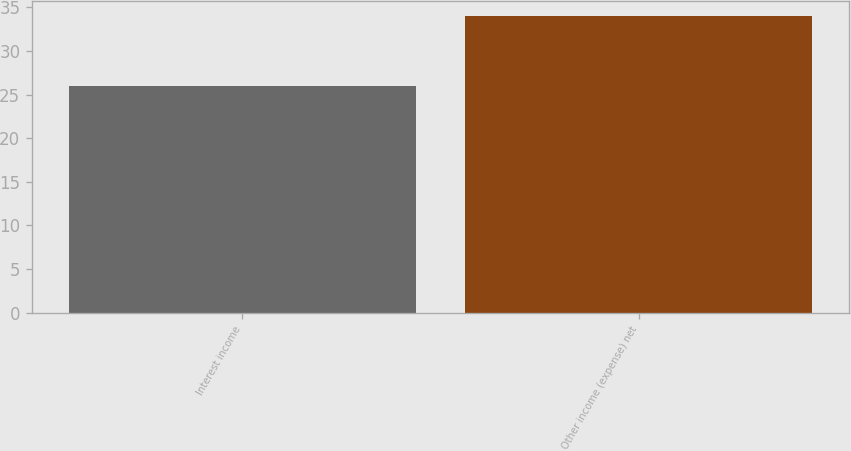Convert chart to OTSL. <chart><loc_0><loc_0><loc_500><loc_500><bar_chart><fcel>Interest income<fcel>Other income (expense) net<nl><fcel>26<fcel>34<nl></chart> 